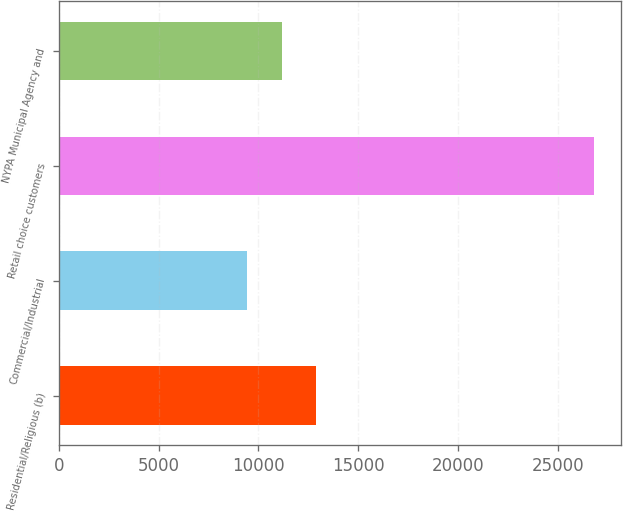Convert chart to OTSL. <chart><loc_0><loc_0><loc_500><loc_500><bar_chart><fcel>Residential/Religious (b)<fcel>Commercial/Industrial<fcel>Retail choice customers<fcel>NYPA Municipal Agency and<nl><fcel>12905.8<fcel>9429<fcel>26813<fcel>11167.4<nl></chart> 